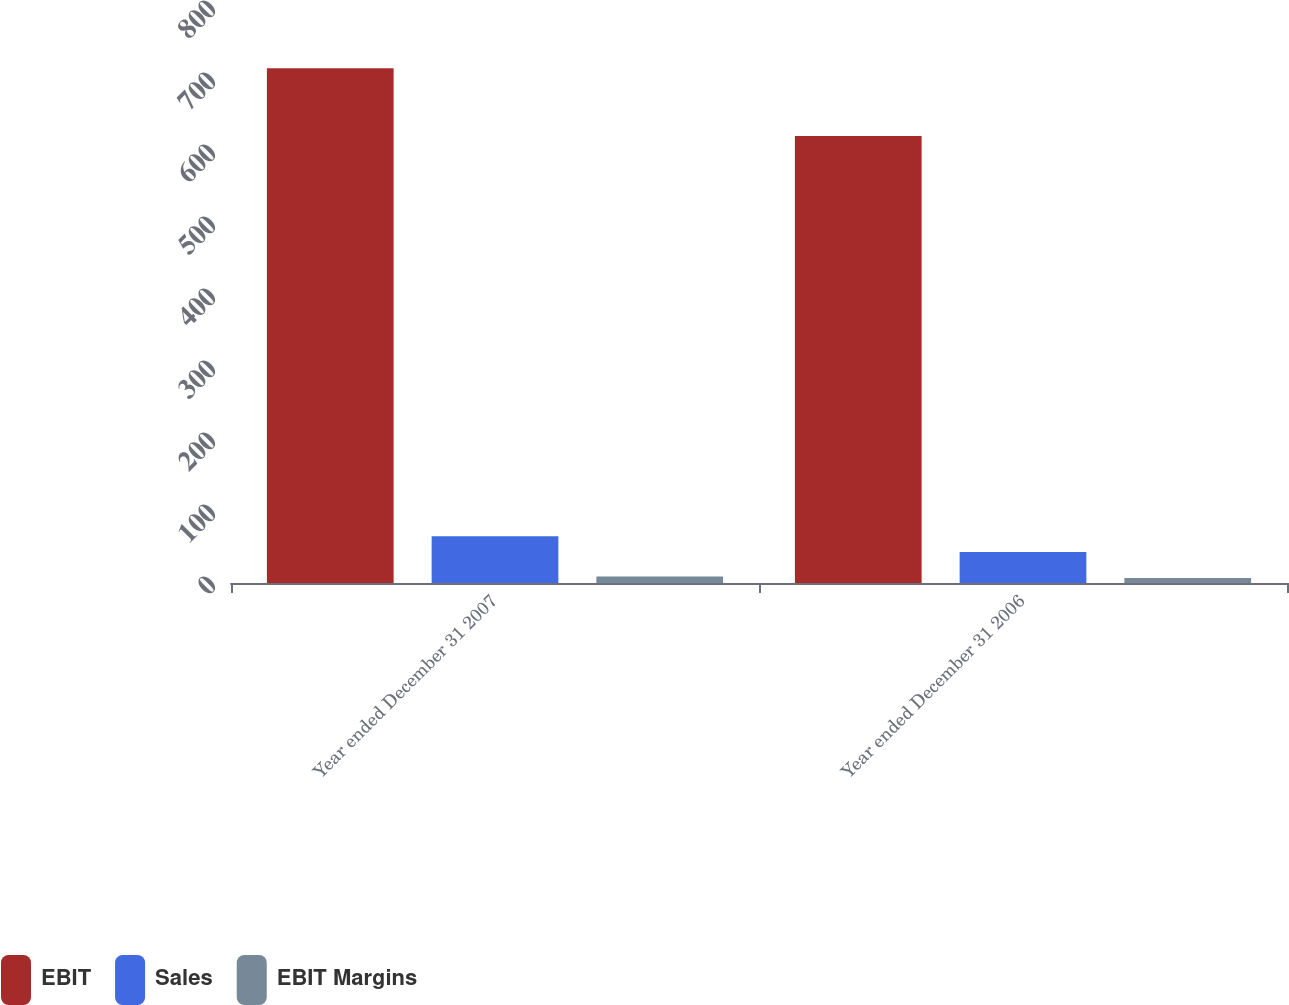Convert chart to OTSL. <chart><loc_0><loc_0><loc_500><loc_500><stacked_bar_chart><ecel><fcel>Year ended December 31 2007<fcel>Year ended December 31 2006<nl><fcel>EBIT<fcel>715<fcel>621<nl><fcel>Sales<fcel>65<fcel>43<nl><fcel>EBIT Margins<fcel>9.1<fcel>6.9<nl></chart> 